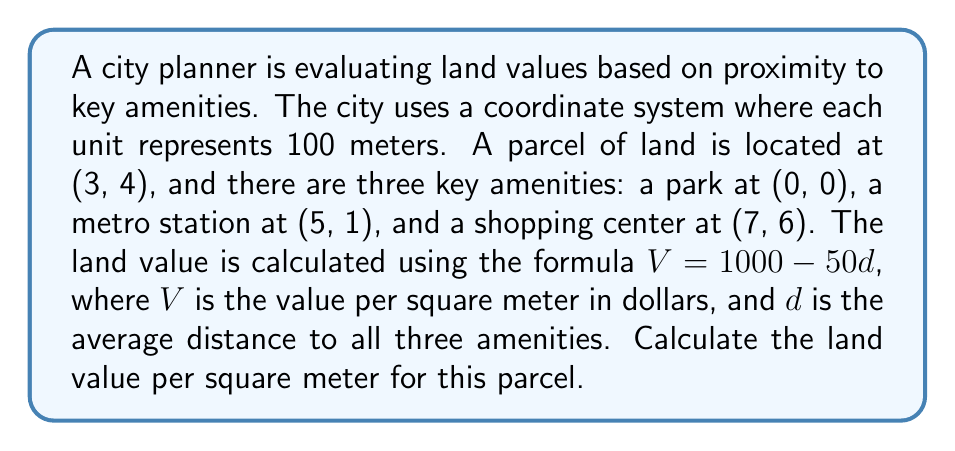Can you answer this question? To solve this problem, we need to follow these steps:

1) Calculate the distance from the land parcel to each amenity using the distance formula:
   $d = \sqrt{(x_2-x_1)^2 + (y_2-y_1)^2}$

2) Find the average of these distances.

3) Use the given formula to calculate the land value.

Step 1: Calculating distances

a) Distance to the park (0, 0):
   $d_1 = \sqrt{(3-0)^2 + (4-0)^2} = \sqrt{9 + 16} = \sqrt{25} = 5$ units

b) Distance to the metro station (5, 1):
   $d_2 = \sqrt{(3-5)^2 + (4-1)^2} = \sqrt{4 + 9} = \sqrt{13}$ units

c) Distance to the shopping center (7, 6):
   $d_3 = \sqrt{(3-7)^2 + (4-6)^2} = \sqrt{16 + 4} = \sqrt{20}$ units

Step 2: Calculate the average distance

$d_{avg} = \frac{d_1 + d_2 + d_3}{3} = \frac{5 + \sqrt{13} + \sqrt{20}}{3}$ units

Step 3: Calculate the land value

$V = 1000 - 50d_{avg}$

$V = 1000 - 50 \cdot \frac{5 + \sqrt{13} + \sqrt{20}}{3}$

$V = 1000 - \frac{250 + 50\sqrt{13} + 50\sqrt{20}}{3}$

Remember that each unit represents 100 meters, so we don't need to adjust the final result.
Answer: The land value per square meter is:

$$V = 1000 - \frac{250 + 50\sqrt{13} + 50\sqrt{20}}{3} \approx 805.27$$ dollars per square meter. 